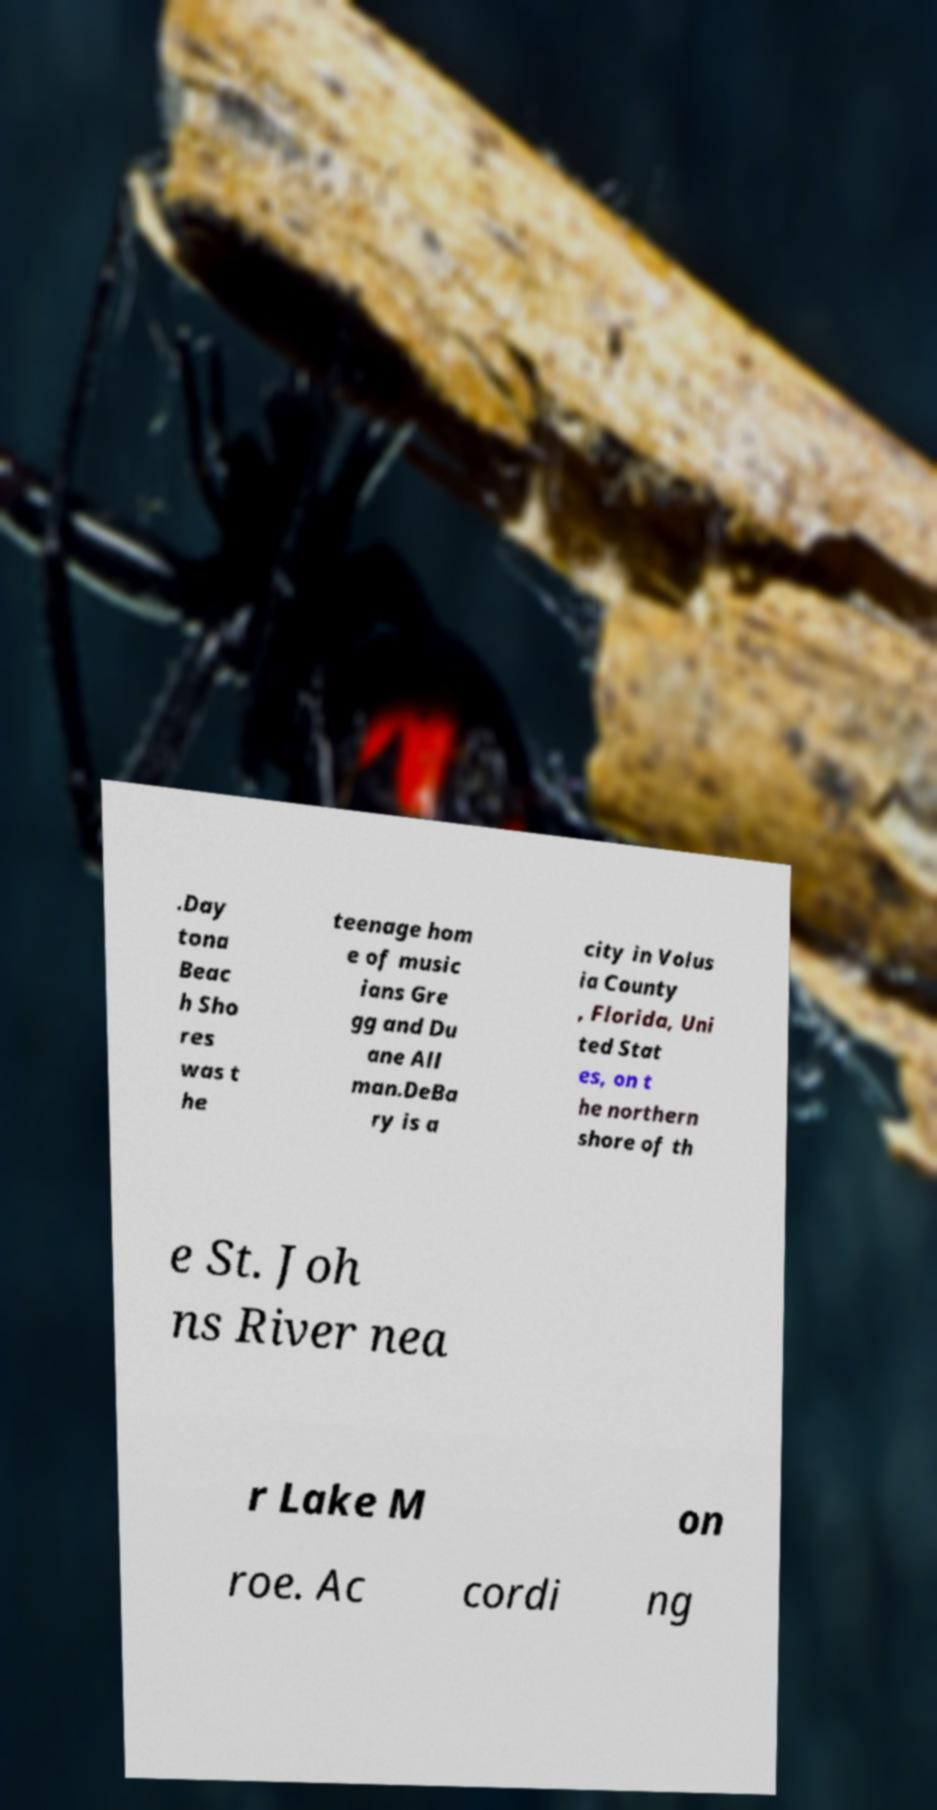Could you extract and type out the text from this image? .Day tona Beac h Sho res was t he teenage hom e of music ians Gre gg and Du ane All man.DeBa ry is a city in Volus ia County , Florida, Uni ted Stat es, on t he northern shore of th e St. Joh ns River nea r Lake M on roe. Ac cordi ng 